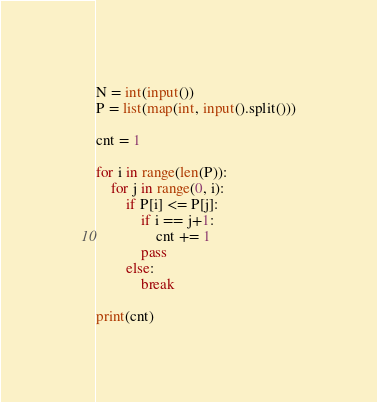<code> <loc_0><loc_0><loc_500><loc_500><_Python_>N = int(input())
P = list(map(int, input().split()))

cnt = 1

for i in range(len(P)):
    for j in range(0, i):
        if P[i] <= P[j]:
            if i == j+1:
                cnt += 1
            pass
        else:
            break

print(cnt)</code> 